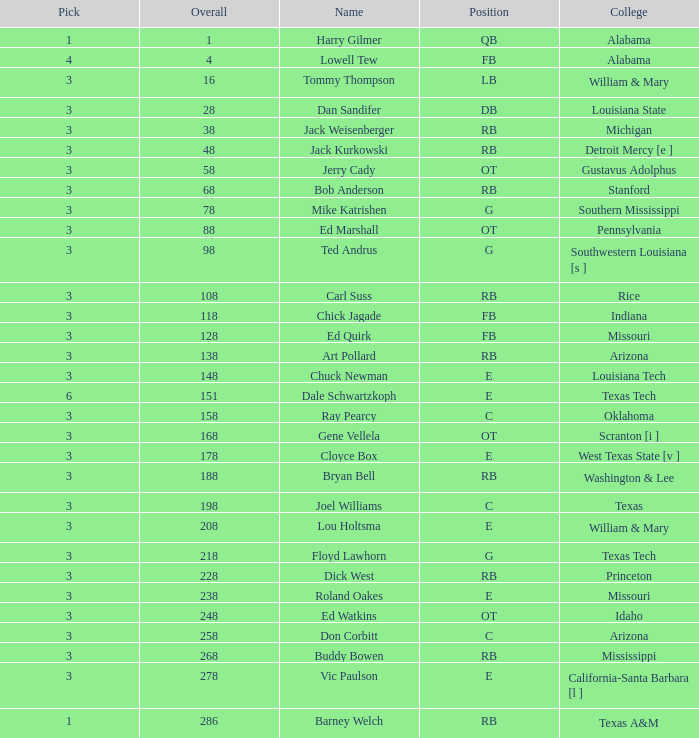Would you be able to parse every entry in this table? {'header': ['Pick', 'Overall', 'Name', 'Position', 'College'], 'rows': [['1', '1', 'Harry Gilmer', 'QB', 'Alabama'], ['4', '4', 'Lowell Tew', 'FB', 'Alabama'], ['3', '16', 'Tommy Thompson', 'LB', 'William & Mary'], ['3', '28', 'Dan Sandifer', 'DB', 'Louisiana State'], ['3', '38', 'Jack Weisenberger', 'RB', 'Michigan'], ['3', '48', 'Jack Kurkowski', 'RB', 'Detroit Mercy [e ]'], ['3', '58', 'Jerry Cady', 'OT', 'Gustavus Adolphus'], ['3', '68', 'Bob Anderson', 'RB', 'Stanford'], ['3', '78', 'Mike Katrishen', 'G', 'Southern Mississippi'], ['3', '88', 'Ed Marshall', 'OT', 'Pennsylvania'], ['3', '98', 'Ted Andrus', 'G', 'Southwestern Louisiana [s ]'], ['3', '108', 'Carl Suss', 'RB', 'Rice'], ['3', '118', 'Chick Jagade', 'FB', 'Indiana'], ['3', '128', 'Ed Quirk', 'FB', 'Missouri'], ['3', '138', 'Art Pollard', 'RB', 'Arizona'], ['3', '148', 'Chuck Newman', 'E', 'Louisiana Tech'], ['6', '151', 'Dale Schwartzkoph', 'E', 'Texas Tech'], ['3', '158', 'Ray Pearcy', 'C', 'Oklahoma'], ['3', '168', 'Gene Vellela', 'OT', 'Scranton [i ]'], ['3', '178', 'Cloyce Box', 'E', 'West Texas State [v ]'], ['3', '188', 'Bryan Bell', 'RB', 'Washington & Lee'], ['3', '198', 'Joel Williams', 'C', 'Texas'], ['3', '208', 'Lou Holtsma', 'E', 'William & Mary'], ['3', '218', 'Floyd Lawhorn', 'G', 'Texas Tech'], ['3', '228', 'Dick West', 'RB', 'Princeton'], ['3', '238', 'Roland Oakes', 'E', 'Missouri'], ['3', '248', 'Ed Watkins', 'OT', 'Idaho'], ['3', '258', 'Don Corbitt', 'C', 'Arizona'], ['3', '268', 'Buddy Bowen', 'RB', 'Mississippi'], ['3', '278', 'Vic Paulson', 'E', 'California-Santa Barbara [l ]'], ['1', '286', 'Barney Welch', 'RB', 'Texas A&M']]} What is stanford's average overall? 68.0. 